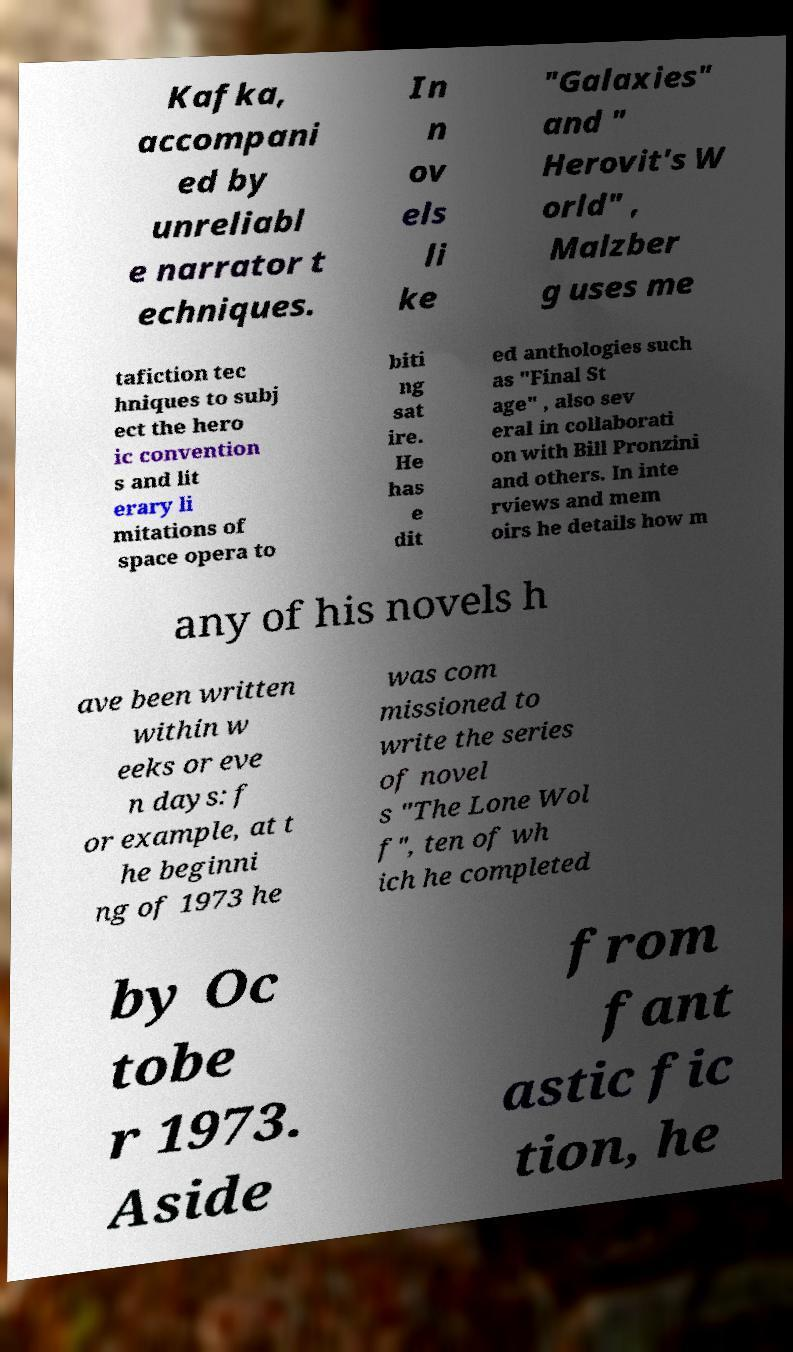There's text embedded in this image that I need extracted. Can you transcribe it verbatim? Kafka, accompani ed by unreliabl e narrator t echniques. In n ov els li ke "Galaxies" and " Herovit's W orld" , Malzber g uses me tafiction tec hniques to subj ect the hero ic convention s and lit erary li mitations of space opera to biti ng sat ire. He has e dit ed anthologies such as "Final St age" , also sev eral in collaborati on with Bill Pronzini and others. In inte rviews and mem oirs he details how m any of his novels h ave been written within w eeks or eve n days: f or example, at t he beginni ng of 1973 he was com missioned to write the series of novel s "The Lone Wol f", ten of wh ich he completed by Oc tobe r 1973. Aside from fant astic fic tion, he 